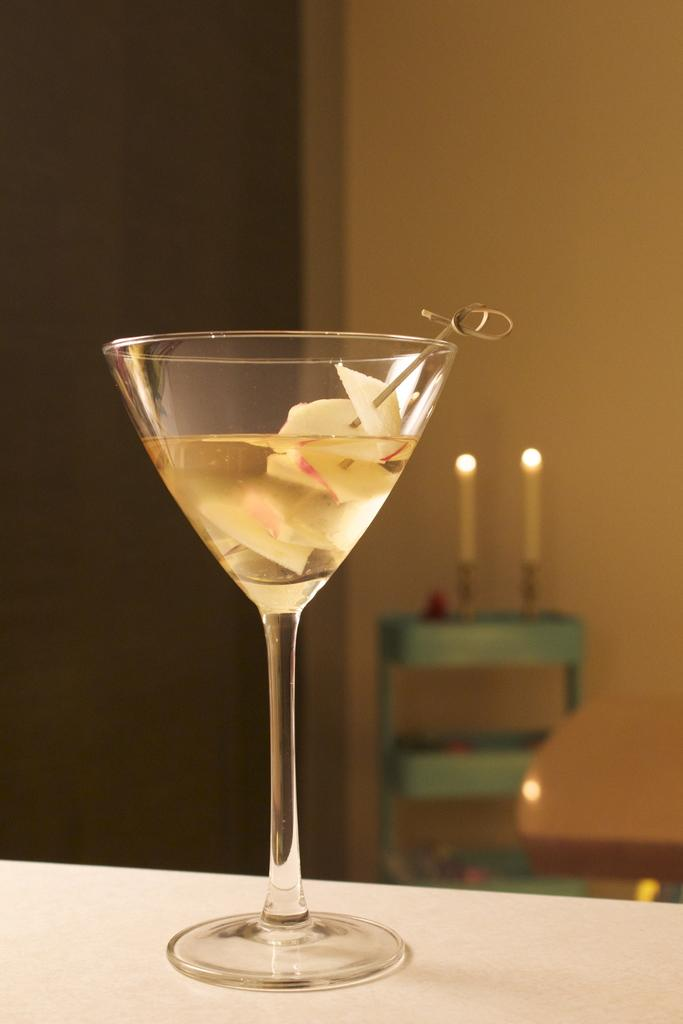What is located in the foreground of the image? There is a glass with liquid in the foreground of the image. Where is the glass placed? The glass is on a table. What can be seen in the background of the image? There are candles on a stand in the background of the image. How close are the candles to a wall? The candles are near a wall. What type of mine can be seen in the image? There is no mine present in the image; it features a glass with liquid, a table, candles on a stand, and a wall. 